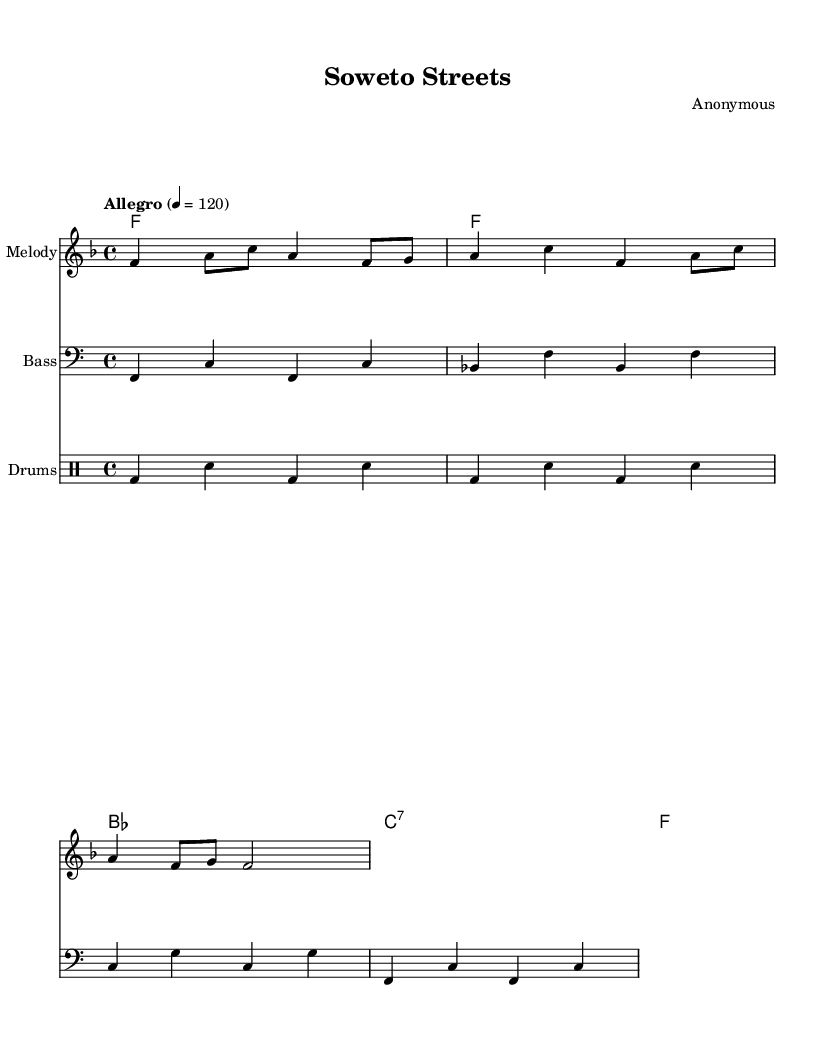What is the key signature of this music? The key signature is F major, which has one flat (B flat). This can be determined by looking at the key signature at the beginning of the staff.
Answer: F major What is the time signature of this music? The time signature is 4/4, which indicates four beats per measure and a quarter note receives one beat. This can be found at the beginning of the score next to the key signature.
Answer: 4/4 What is the tempo marking in this piece? The tempo marking is "Allegro," which indicates a fast-paced performance. The specific BPM (beats per minute) is marked as 120, which tells the musician how fast to play. This is indicated below the title in the score.
Answer: Allegro Which instrument plays the melody? The melody is played by the instrument labeled as "Melody" in the score, which is typically a treble clef staff. This is indicated just above the staff where the melody is notated.
Answer: Melody How many measures are in the melody? The melody consists of four measures, and this can be counted by looking at the bars separating the musical phrases. Each segment between vertical lines represents one measure.
Answer: Four What type of music does this piece represent? This piece represents South African township jive, reflecting urban black experiences during apartheid, as indicated by its style and cultural context inferred from the title. This is a specific genre of World Music noted in discussions of the piece.
Answer: South African township jive What is the form of the melody? The form of the melody is AABA, where the A sections repeat and are followed by a contrasting B section. This can be deduced by analyzing the structure of the melodic phrases in the piece.
Answer: AABA 